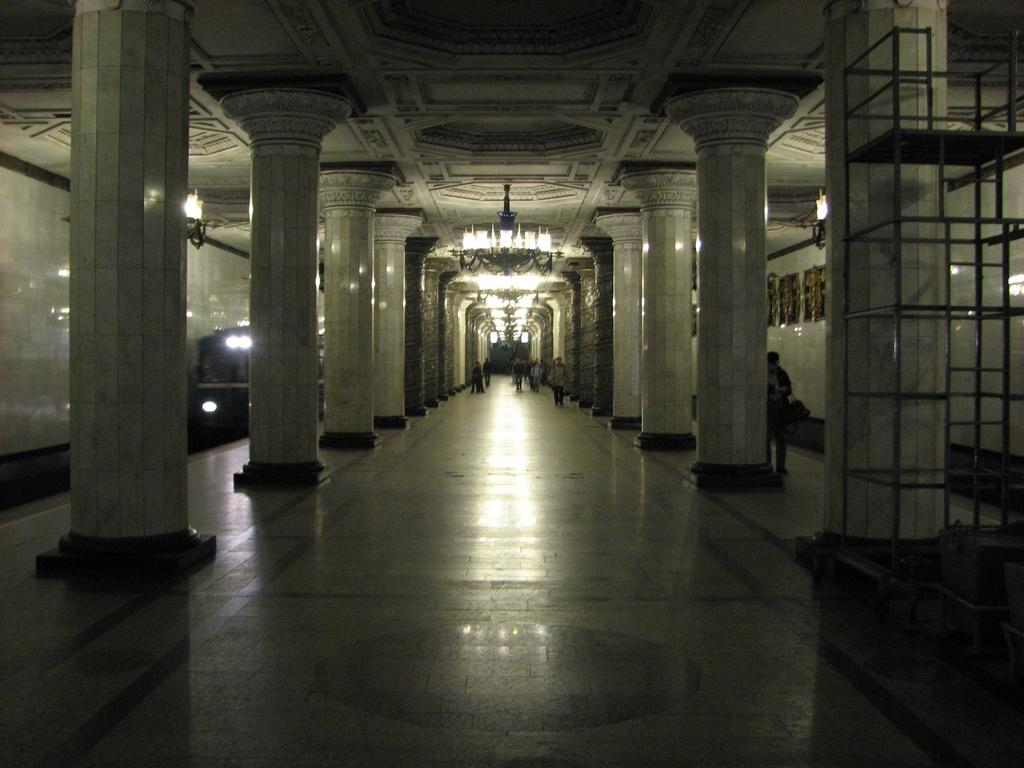How many people are in the group visible in the image? There is a group of people standing in the image, but the exact number cannot be determined from the provided facts. What architectural features can be seen in the image? There are pillars and chandeliers visible in the image. What mode of transportation is present in the image? There is a train in the image. Can you see any deer in the cemetery near the train in the image? There is no mention of a cemetery or deer in the provided facts, and therefore they cannot be observed in the image. 